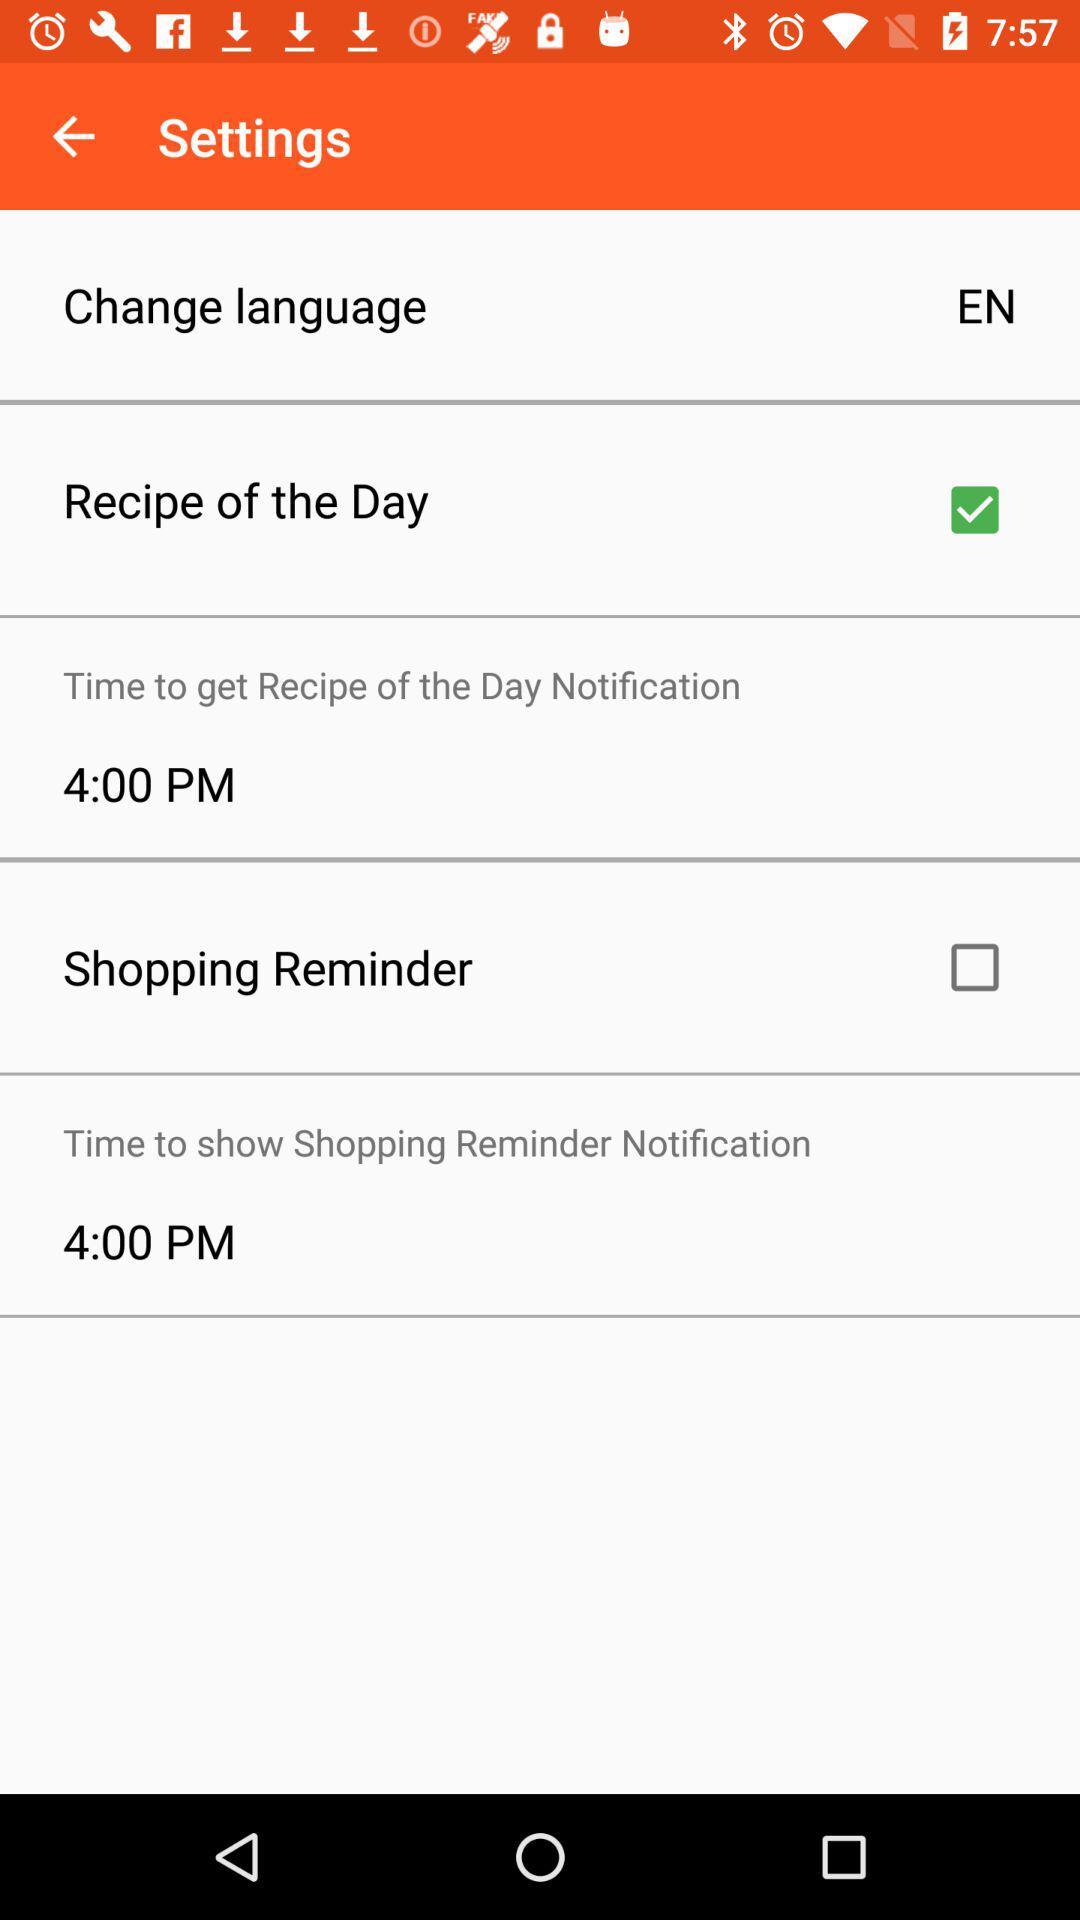What is the "Time to get Recipe of the Day Notification"? The time is 4:00 PM. 